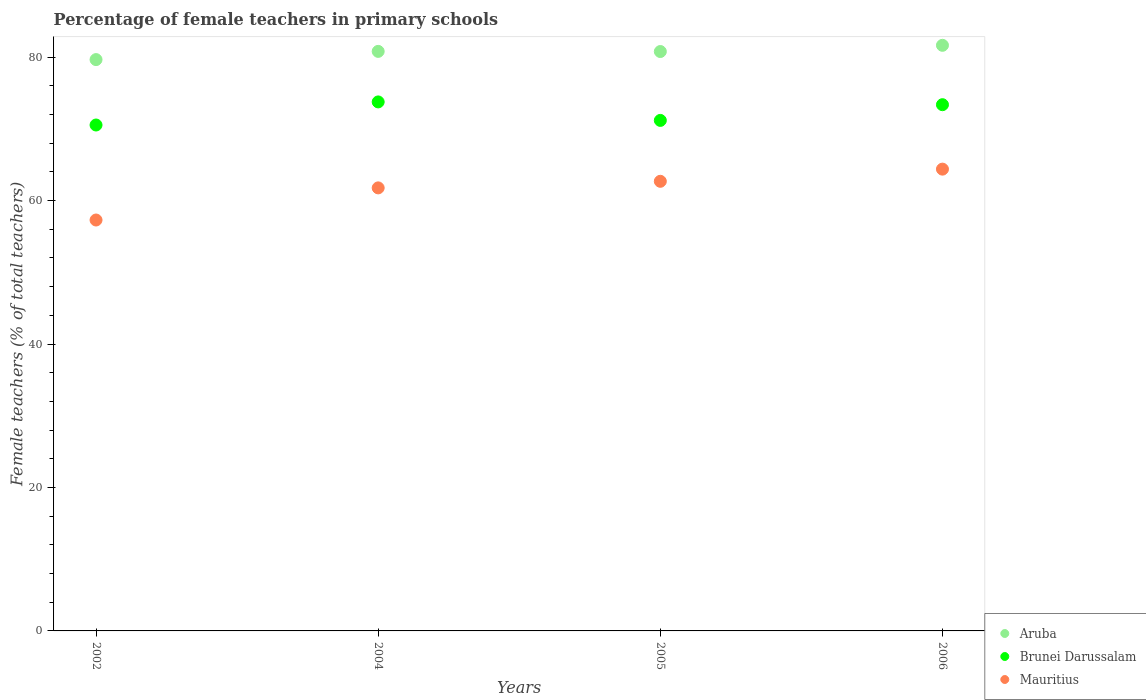How many different coloured dotlines are there?
Your response must be concise. 3. Is the number of dotlines equal to the number of legend labels?
Keep it short and to the point. Yes. What is the percentage of female teachers in Mauritius in 2004?
Provide a short and direct response. 61.77. Across all years, what is the maximum percentage of female teachers in Mauritius?
Your answer should be very brief. 64.38. Across all years, what is the minimum percentage of female teachers in Brunei Darussalam?
Provide a short and direct response. 70.53. What is the total percentage of female teachers in Brunei Darussalam in the graph?
Provide a succinct answer. 288.82. What is the difference between the percentage of female teachers in Brunei Darussalam in 2002 and that in 2006?
Keep it short and to the point. -2.83. What is the difference between the percentage of female teachers in Brunei Darussalam in 2004 and the percentage of female teachers in Aruba in 2005?
Your response must be concise. -7.03. What is the average percentage of female teachers in Aruba per year?
Your response must be concise. 80.72. In the year 2006, what is the difference between the percentage of female teachers in Brunei Darussalam and percentage of female teachers in Aruba?
Make the answer very short. -8.28. In how many years, is the percentage of female teachers in Brunei Darussalam greater than 4 %?
Make the answer very short. 4. What is the ratio of the percentage of female teachers in Mauritius in 2004 to that in 2005?
Provide a succinct answer. 0.99. What is the difference between the highest and the second highest percentage of female teachers in Aruba?
Offer a very short reply. 0.85. What is the difference between the highest and the lowest percentage of female teachers in Mauritius?
Your answer should be compact. 7.09. Is the sum of the percentage of female teachers in Aruba in 2004 and 2006 greater than the maximum percentage of female teachers in Brunei Darussalam across all years?
Keep it short and to the point. Yes. Is the percentage of female teachers in Brunei Darussalam strictly greater than the percentage of female teachers in Mauritius over the years?
Provide a succinct answer. Yes. Is the percentage of female teachers in Aruba strictly less than the percentage of female teachers in Brunei Darussalam over the years?
Offer a terse response. No. How many years are there in the graph?
Provide a short and direct response. 4. What is the difference between two consecutive major ticks on the Y-axis?
Your response must be concise. 20. Are the values on the major ticks of Y-axis written in scientific E-notation?
Keep it short and to the point. No. Does the graph contain any zero values?
Offer a terse response. No. Does the graph contain grids?
Your answer should be compact. No. How many legend labels are there?
Provide a short and direct response. 3. How are the legend labels stacked?
Make the answer very short. Vertical. What is the title of the graph?
Give a very brief answer. Percentage of female teachers in primary schools. What is the label or title of the Y-axis?
Your answer should be compact. Female teachers (% of total teachers). What is the Female teachers (% of total teachers) of Aruba in 2002?
Provide a short and direct response. 79.65. What is the Female teachers (% of total teachers) of Brunei Darussalam in 2002?
Provide a succinct answer. 70.53. What is the Female teachers (% of total teachers) in Mauritius in 2002?
Your response must be concise. 57.29. What is the Female teachers (% of total teachers) of Aruba in 2004?
Your answer should be very brief. 80.8. What is the Female teachers (% of total teachers) in Brunei Darussalam in 2004?
Make the answer very short. 73.75. What is the Female teachers (% of total teachers) of Mauritius in 2004?
Your answer should be compact. 61.77. What is the Female teachers (% of total teachers) in Aruba in 2005?
Offer a terse response. 80.78. What is the Female teachers (% of total teachers) in Brunei Darussalam in 2005?
Ensure brevity in your answer.  71.17. What is the Female teachers (% of total teachers) of Mauritius in 2005?
Your response must be concise. 62.68. What is the Female teachers (% of total teachers) of Aruba in 2006?
Your answer should be compact. 81.64. What is the Female teachers (% of total teachers) in Brunei Darussalam in 2006?
Keep it short and to the point. 73.36. What is the Female teachers (% of total teachers) of Mauritius in 2006?
Keep it short and to the point. 64.38. Across all years, what is the maximum Female teachers (% of total teachers) in Aruba?
Make the answer very short. 81.64. Across all years, what is the maximum Female teachers (% of total teachers) in Brunei Darussalam?
Your answer should be very brief. 73.75. Across all years, what is the maximum Female teachers (% of total teachers) in Mauritius?
Keep it short and to the point. 64.38. Across all years, what is the minimum Female teachers (% of total teachers) in Aruba?
Keep it short and to the point. 79.65. Across all years, what is the minimum Female teachers (% of total teachers) of Brunei Darussalam?
Keep it short and to the point. 70.53. Across all years, what is the minimum Female teachers (% of total teachers) in Mauritius?
Ensure brevity in your answer.  57.29. What is the total Female teachers (% of total teachers) in Aruba in the graph?
Your answer should be compact. 322.87. What is the total Female teachers (% of total teachers) in Brunei Darussalam in the graph?
Offer a very short reply. 288.82. What is the total Female teachers (% of total teachers) in Mauritius in the graph?
Make the answer very short. 246.12. What is the difference between the Female teachers (% of total teachers) of Aruba in 2002 and that in 2004?
Offer a very short reply. -1.15. What is the difference between the Female teachers (% of total teachers) of Brunei Darussalam in 2002 and that in 2004?
Make the answer very short. -3.22. What is the difference between the Female teachers (% of total teachers) in Mauritius in 2002 and that in 2004?
Your response must be concise. -4.48. What is the difference between the Female teachers (% of total teachers) of Aruba in 2002 and that in 2005?
Your answer should be compact. -1.12. What is the difference between the Female teachers (% of total teachers) of Brunei Darussalam in 2002 and that in 2005?
Ensure brevity in your answer.  -0.64. What is the difference between the Female teachers (% of total teachers) of Mauritius in 2002 and that in 2005?
Ensure brevity in your answer.  -5.4. What is the difference between the Female teachers (% of total teachers) of Aruba in 2002 and that in 2006?
Make the answer very short. -1.99. What is the difference between the Female teachers (% of total teachers) of Brunei Darussalam in 2002 and that in 2006?
Your response must be concise. -2.83. What is the difference between the Female teachers (% of total teachers) of Mauritius in 2002 and that in 2006?
Provide a short and direct response. -7.09. What is the difference between the Female teachers (% of total teachers) of Aruba in 2004 and that in 2005?
Ensure brevity in your answer.  0.02. What is the difference between the Female teachers (% of total teachers) in Brunei Darussalam in 2004 and that in 2005?
Keep it short and to the point. 2.58. What is the difference between the Female teachers (% of total teachers) of Mauritius in 2004 and that in 2005?
Make the answer very short. -0.92. What is the difference between the Female teachers (% of total teachers) in Aruba in 2004 and that in 2006?
Provide a succinct answer. -0.85. What is the difference between the Female teachers (% of total teachers) of Brunei Darussalam in 2004 and that in 2006?
Make the answer very short. 0.39. What is the difference between the Female teachers (% of total teachers) of Mauritius in 2004 and that in 2006?
Offer a terse response. -2.61. What is the difference between the Female teachers (% of total teachers) of Aruba in 2005 and that in 2006?
Offer a very short reply. -0.87. What is the difference between the Female teachers (% of total teachers) in Brunei Darussalam in 2005 and that in 2006?
Offer a very short reply. -2.19. What is the difference between the Female teachers (% of total teachers) in Mauritius in 2005 and that in 2006?
Offer a terse response. -1.7. What is the difference between the Female teachers (% of total teachers) of Aruba in 2002 and the Female teachers (% of total teachers) of Brunei Darussalam in 2004?
Offer a very short reply. 5.9. What is the difference between the Female teachers (% of total teachers) of Aruba in 2002 and the Female teachers (% of total teachers) of Mauritius in 2004?
Provide a short and direct response. 17.88. What is the difference between the Female teachers (% of total teachers) of Brunei Darussalam in 2002 and the Female teachers (% of total teachers) of Mauritius in 2004?
Your response must be concise. 8.77. What is the difference between the Female teachers (% of total teachers) in Aruba in 2002 and the Female teachers (% of total teachers) in Brunei Darussalam in 2005?
Ensure brevity in your answer.  8.48. What is the difference between the Female teachers (% of total teachers) of Aruba in 2002 and the Female teachers (% of total teachers) of Mauritius in 2005?
Your answer should be very brief. 16.97. What is the difference between the Female teachers (% of total teachers) in Brunei Darussalam in 2002 and the Female teachers (% of total teachers) in Mauritius in 2005?
Ensure brevity in your answer.  7.85. What is the difference between the Female teachers (% of total teachers) in Aruba in 2002 and the Female teachers (% of total teachers) in Brunei Darussalam in 2006?
Keep it short and to the point. 6.29. What is the difference between the Female teachers (% of total teachers) of Aruba in 2002 and the Female teachers (% of total teachers) of Mauritius in 2006?
Your answer should be very brief. 15.27. What is the difference between the Female teachers (% of total teachers) of Brunei Darussalam in 2002 and the Female teachers (% of total teachers) of Mauritius in 2006?
Make the answer very short. 6.15. What is the difference between the Female teachers (% of total teachers) of Aruba in 2004 and the Female teachers (% of total teachers) of Brunei Darussalam in 2005?
Ensure brevity in your answer.  9.62. What is the difference between the Female teachers (% of total teachers) of Aruba in 2004 and the Female teachers (% of total teachers) of Mauritius in 2005?
Your response must be concise. 18.11. What is the difference between the Female teachers (% of total teachers) of Brunei Darussalam in 2004 and the Female teachers (% of total teachers) of Mauritius in 2005?
Ensure brevity in your answer.  11.07. What is the difference between the Female teachers (% of total teachers) in Aruba in 2004 and the Female teachers (% of total teachers) in Brunei Darussalam in 2006?
Provide a succinct answer. 7.43. What is the difference between the Female teachers (% of total teachers) of Aruba in 2004 and the Female teachers (% of total teachers) of Mauritius in 2006?
Provide a short and direct response. 16.42. What is the difference between the Female teachers (% of total teachers) in Brunei Darussalam in 2004 and the Female teachers (% of total teachers) in Mauritius in 2006?
Make the answer very short. 9.37. What is the difference between the Female teachers (% of total teachers) in Aruba in 2005 and the Female teachers (% of total teachers) in Brunei Darussalam in 2006?
Ensure brevity in your answer.  7.41. What is the difference between the Female teachers (% of total teachers) of Aruba in 2005 and the Female teachers (% of total teachers) of Mauritius in 2006?
Offer a terse response. 16.4. What is the difference between the Female teachers (% of total teachers) of Brunei Darussalam in 2005 and the Female teachers (% of total teachers) of Mauritius in 2006?
Provide a short and direct response. 6.79. What is the average Female teachers (% of total teachers) in Aruba per year?
Keep it short and to the point. 80.72. What is the average Female teachers (% of total teachers) of Brunei Darussalam per year?
Your answer should be compact. 72.21. What is the average Female teachers (% of total teachers) in Mauritius per year?
Provide a succinct answer. 61.53. In the year 2002, what is the difference between the Female teachers (% of total teachers) in Aruba and Female teachers (% of total teachers) in Brunei Darussalam?
Your answer should be compact. 9.12. In the year 2002, what is the difference between the Female teachers (% of total teachers) of Aruba and Female teachers (% of total teachers) of Mauritius?
Your response must be concise. 22.36. In the year 2002, what is the difference between the Female teachers (% of total teachers) of Brunei Darussalam and Female teachers (% of total teachers) of Mauritius?
Provide a succinct answer. 13.24. In the year 2004, what is the difference between the Female teachers (% of total teachers) of Aruba and Female teachers (% of total teachers) of Brunei Darussalam?
Your answer should be very brief. 7.05. In the year 2004, what is the difference between the Female teachers (% of total teachers) in Aruba and Female teachers (% of total teachers) in Mauritius?
Your response must be concise. 19.03. In the year 2004, what is the difference between the Female teachers (% of total teachers) in Brunei Darussalam and Female teachers (% of total teachers) in Mauritius?
Provide a succinct answer. 11.98. In the year 2005, what is the difference between the Female teachers (% of total teachers) of Aruba and Female teachers (% of total teachers) of Brunei Darussalam?
Keep it short and to the point. 9.6. In the year 2005, what is the difference between the Female teachers (% of total teachers) in Aruba and Female teachers (% of total teachers) in Mauritius?
Your answer should be very brief. 18.09. In the year 2005, what is the difference between the Female teachers (% of total teachers) of Brunei Darussalam and Female teachers (% of total teachers) of Mauritius?
Keep it short and to the point. 8.49. In the year 2006, what is the difference between the Female teachers (% of total teachers) of Aruba and Female teachers (% of total teachers) of Brunei Darussalam?
Ensure brevity in your answer.  8.28. In the year 2006, what is the difference between the Female teachers (% of total teachers) of Aruba and Female teachers (% of total teachers) of Mauritius?
Offer a terse response. 17.26. In the year 2006, what is the difference between the Female teachers (% of total teachers) of Brunei Darussalam and Female teachers (% of total teachers) of Mauritius?
Offer a very short reply. 8.98. What is the ratio of the Female teachers (% of total teachers) of Aruba in 2002 to that in 2004?
Provide a short and direct response. 0.99. What is the ratio of the Female teachers (% of total teachers) of Brunei Darussalam in 2002 to that in 2004?
Your response must be concise. 0.96. What is the ratio of the Female teachers (% of total teachers) of Mauritius in 2002 to that in 2004?
Provide a short and direct response. 0.93. What is the ratio of the Female teachers (% of total teachers) of Aruba in 2002 to that in 2005?
Offer a terse response. 0.99. What is the ratio of the Female teachers (% of total teachers) in Mauritius in 2002 to that in 2005?
Give a very brief answer. 0.91. What is the ratio of the Female teachers (% of total teachers) of Aruba in 2002 to that in 2006?
Offer a very short reply. 0.98. What is the ratio of the Female teachers (% of total teachers) of Brunei Darussalam in 2002 to that in 2006?
Your answer should be compact. 0.96. What is the ratio of the Female teachers (% of total teachers) in Mauritius in 2002 to that in 2006?
Ensure brevity in your answer.  0.89. What is the ratio of the Female teachers (% of total teachers) in Brunei Darussalam in 2004 to that in 2005?
Provide a succinct answer. 1.04. What is the ratio of the Female teachers (% of total teachers) of Mauritius in 2004 to that in 2005?
Give a very brief answer. 0.99. What is the ratio of the Female teachers (% of total teachers) in Mauritius in 2004 to that in 2006?
Provide a short and direct response. 0.96. What is the ratio of the Female teachers (% of total teachers) in Brunei Darussalam in 2005 to that in 2006?
Provide a succinct answer. 0.97. What is the ratio of the Female teachers (% of total teachers) in Mauritius in 2005 to that in 2006?
Offer a very short reply. 0.97. What is the difference between the highest and the second highest Female teachers (% of total teachers) of Aruba?
Offer a very short reply. 0.85. What is the difference between the highest and the second highest Female teachers (% of total teachers) in Brunei Darussalam?
Give a very brief answer. 0.39. What is the difference between the highest and the second highest Female teachers (% of total teachers) in Mauritius?
Offer a terse response. 1.7. What is the difference between the highest and the lowest Female teachers (% of total teachers) in Aruba?
Offer a terse response. 1.99. What is the difference between the highest and the lowest Female teachers (% of total teachers) of Brunei Darussalam?
Your response must be concise. 3.22. What is the difference between the highest and the lowest Female teachers (% of total teachers) of Mauritius?
Offer a very short reply. 7.09. 